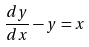<formula> <loc_0><loc_0><loc_500><loc_500>\frac { d y } { d x } - y = x</formula> 